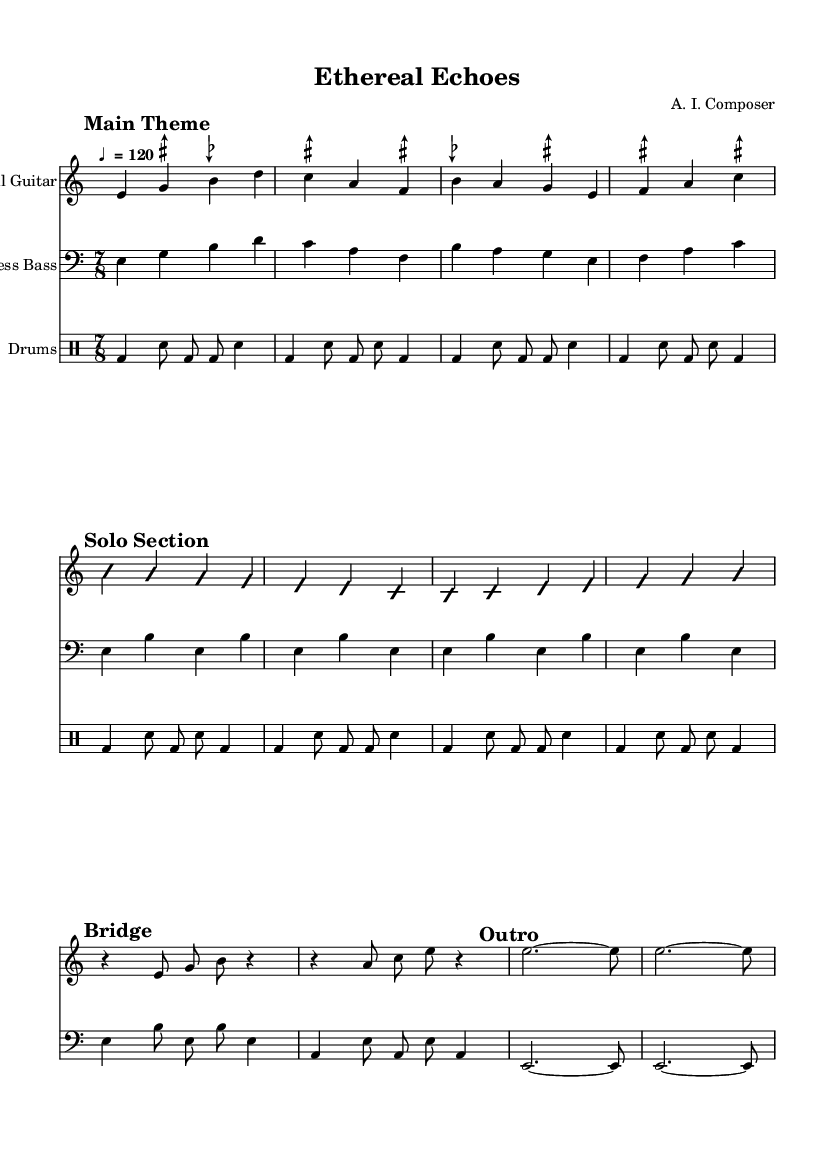What is the time signature of this music? The time signature at the beginning of the score indicates 7/8, showing that there are seven beats per measure, and the eighth note is the beat unit.
Answer: 7/8 What is the tempo marking in this sheet music? The tempo marking specifies that the quarter note equals 120 beats per minute, meaning the piece should be played fairly quickly.
Answer: ♩ = 120 How many sections are present in the composition? Upon examining the music, there are four distinct sections: Main Theme, Solo Section, Bridge, and Outro.
Answer: Four What type of guitar is indicated in the score? The score specifies the instrument name as "Microtonal Guitar," which suggests the guitar is designed to play microtones, fitting the experimental style.
Answer: Microtonal Guitar What rhythmic feel is achieved in the Solo Section? The Solo Section features improvisation, noted by the "improvisationOn" marking which implies flexibility in rhythm and pitches, characteristic of jazz fusion styles.
Answer: Improvisation How does the bass line support the overall structure in this piece? The bass line serves as a foundation, maintaining thematic elements and rhythmic stability while interplaying with the guitar in various sections.
Answer: Foundation 